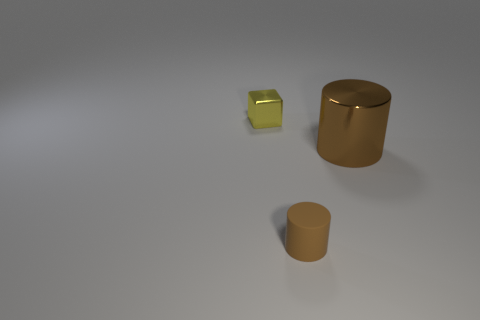What is the material of the other object that is the same color as the matte thing?
Provide a short and direct response. Metal. Are there the same number of tiny brown objects that are in front of the big brown object and blocks?
Offer a very short reply. Yes. Is there anything else that has the same shape as the tiny yellow shiny object?
Give a very brief answer. No. Is the shape of the small yellow metallic thing the same as the thing in front of the large brown cylinder?
Offer a terse response. No. What size is the other thing that is the same shape as the big brown thing?
Offer a terse response. Small. What number of other objects are the same material as the yellow cube?
Offer a terse response. 1. What is the material of the small brown object?
Your response must be concise. Rubber. There is a cylinder that is to the left of the large brown thing; does it have the same color as the tiny object that is behind the small brown matte object?
Keep it short and to the point. No. Is the number of cylinders in front of the brown shiny thing greater than the number of tiny shiny cubes?
Your answer should be compact. No. What number of other objects are the same color as the tiny rubber cylinder?
Give a very brief answer. 1. 